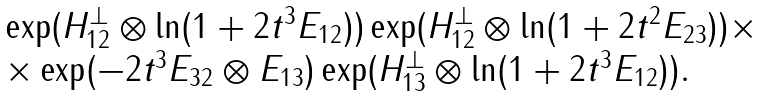<formula> <loc_0><loc_0><loc_500><loc_500>\begin{array} { l } \exp ( H _ { 1 2 } ^ { \perp } \otimes \ln ( 1 + 2 t ^ { 3 } E _ { 1 2 } ) ) \exp ( H _ { 1 2 } ^ { \perp } \otimes \ln ( 1 + 2 t ^ { 2 } E _ { 2 3 } ) ) \times \\ \times \exp ( - 2 t ^ { 3 } E _ { 3 2 } \otimes E _ { 1 3 } ) \exp ( H _ { 1 3 } ^ { \perp } \otimes \ln ( 1 + 2 t ^ { 3 } E _ { 1 2 } ) ) . \end{array}</formula> 